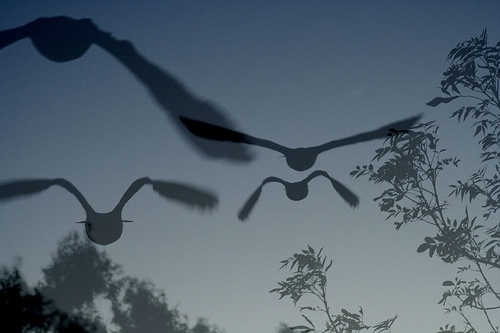Describe the objects in this image and their specific colors. I can see bird in navy, black, darkblue, and blue tones, bird in navy, black, gray, blue, and darkblue tones, bird in navy, black, blue, and darkblue tones, and bird in navy, black, and gray tones in this image. 